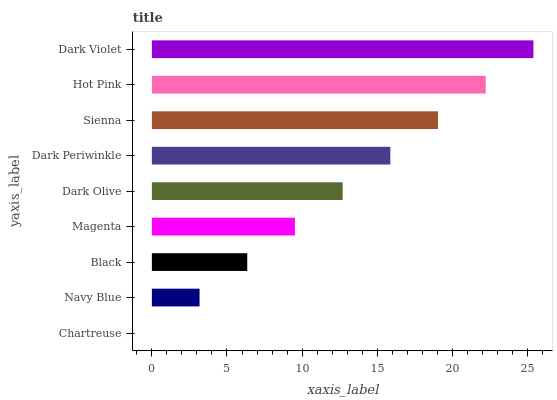Is Chartreuse the minimum?
Answer yes or no. Yes. Is Dark Violet the maximum?
Answer yes or no. Yes. Is Navy Blue the minimum?
Answer yes or no. No. Is Navy Blue the maximum?
Answer yes or no. No. Is Navy Blue greater than Chartreuse?
Answer yes or no. Yes. Is Chartreuse less than Navy Blue?
Answer yes or no. Yes. Is Chartreuse greater than Navy Blue?
Answer yes or no. No. Is Navy Blue less than Chartreuse?
Answer yes or no. No. Is Dark Olive the high median?
Answer yes or no. Yes. Is Dark Olive the low median?
Answer yes or no. Yes. Is Navy Blue the high median?
Answer yes or no. No. Is Dark Violet the low median?
Answer yes or no. No. 